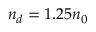<formula> <loc_0><loc_0><loc_500><loc_500>n _ { d } = 1 . 2 5 n _ { 0 }</formula> 